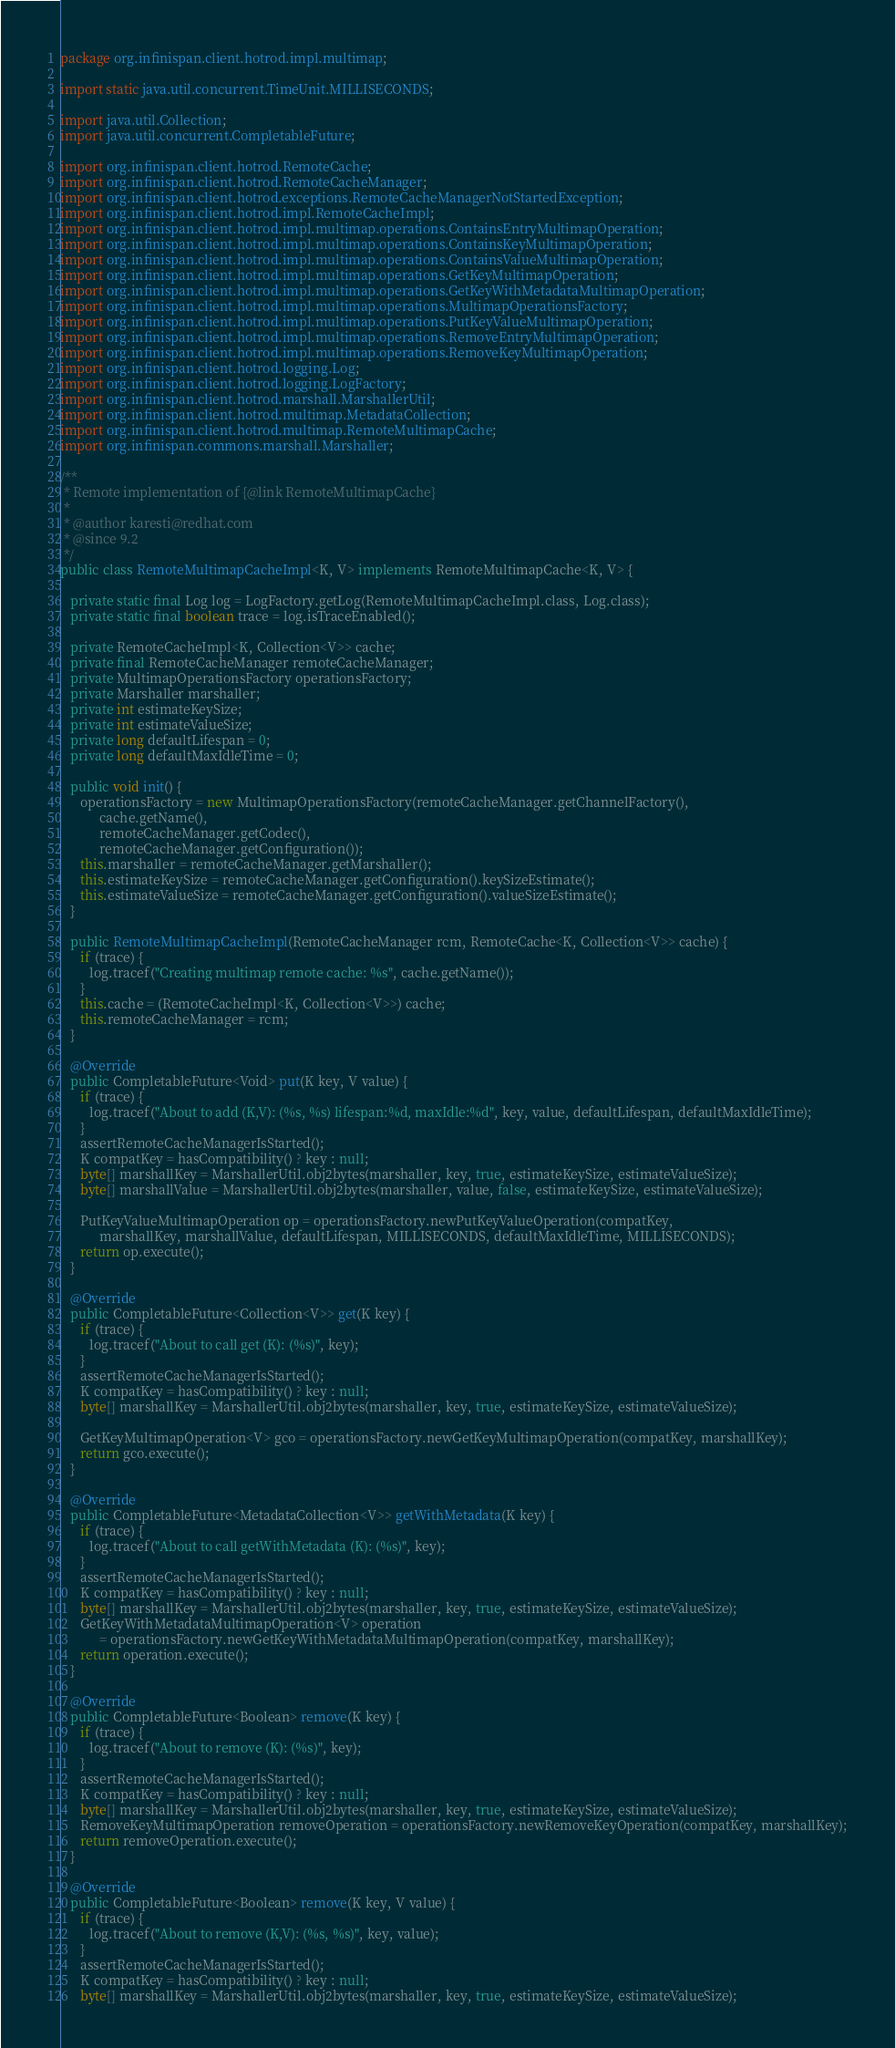<code> <loc_0><loc_0><loc_500><loc_500><_Java_>package org.infinispan.client.hotrod.impl.multimap;

import static java.util.concurrent.TimeUnit.MILLISECONDS;

import java.util.Collection;
import java.util.concurrent.CompletableFuture;

import org.infinispan.client.hotrod.RemoteCache;
import org.infinispan.client.hotrod.RemoteCacheManager;
import org.infinispan.client.hotrod.exceptions.RemoteCacheManagerNotStartedException;
import org.infinispan.client.hotrod.impl.RemoteCacheImpl;
import org.infinispan.client.hotrod.impl.multimap.operations.ContainsEntryMultimapOperation;
import org.infinispan.client.hotrod.impl.multimap.operations.ContainsKeyMultimapOperation;
import org.infinispan.client.hotrod.impl.multimap.operations.ContainsValueMultimapOperation;
import org.infinispan.client.hotrod.impl.multimap.operations.GetKeyMultimapOperation;
import org.infinispan.client.hotrod.impl.multimap.operations.GetKeyWithMetadataMultimapOperation;
import org.infinispan.client.hotrod.impl.multimap.operations.MultimapOperationsFactory;
import org.infinispan.client.hotrod.impl.multimap.operations.PutKeyValueMultimapOperation;
import org.infinispan.client.hotrod.impl.multimap.operations.RemoveEntryMultimapOperation;
import org.infinispan.client.hotrod.impl.multimap.operations.RemoveKeyMultimapOperation;
import org.infinispan.client.hotrod.logging.Log;
import org.infinispan.client.hotrod.logging.LogFactory;
import org.infinispan.client.hotrod.marshall.MarshallerUtil;
import org.infinispan.client.hotrod.multimap.MetadataCollection;
import org.infinispan.client.hotrod.multimap.RemoteMultimapCache;
import org.infinispan.commons.marshall.Marshaller;

/**
 * Remote implementation of {@link RemoteMultimapCache}
 *
 * @author karesti@redhat.com
 * @since 9.2
 */
public class RemoteMultimapCacheImpl<K, V> implements RemoteMultimapCache<K, V> {

   private static final Log log = LogFactory.getLog(RemoteMultimapCacheImpl.class, Log.class);
   private static final boolean trace = log.isTraceEnabled();

   private RemoteCacheImpl<K, Collection<V>> cache;
   private final RemoteCacheManager remoteCacheManager;
   private MultimapOperationsFactory operationsFactory;
   private Marshaller marshaller;
   private int estimateKeySize;
   private int estimateValueSize;
   private long defaultLifespan = 0;
   private long defaultMaxIdleTime = 0;

   public void init() {
      operationsFactory = new MultimapOperationsFactory(remoteCacheManager.getChannelFactory(),
            cache.getName(),
            remoteCacheManager.getCodec(),
            remoteCacheManager.getConfiguration());
      this.marshaller = remoteCacheManager.getMarshaller();
      this.estimateKeySize = remoteCacheManager.getConfiguration().keySizeEstimate();
      this.estimateValueSize = remoteCacheManager.getConfiguration().valueSizeEstimate();
   }

   public RemoteMultimapCacheImpl(RemoteCacheManager rcm, RemoteCache<K, Collection<V>> cache) {
      if (trace) {
         log.tracef("Creating multimap remote cache: %s", cache.getName());
      }
      this.cache = (RemoteCacheImpl<K, Collection<V>>) cache;
      this.remoteCacheManager = rcm;
   }

   @Override
   public CompletableFuture<Void> put(K key, V value) {
      if (trace) {
         log.tracef("About to add (K,V): (%s, %s) lifespan:%d, maxIdle:%d", key, value, defaultLifespan, defaultMaxIdleTime);
      }
      assertRemoteCacheManagerIsStarted();
      K compatKey = hasCompatibility() ? key : null;
      byte[] marshallKey = MarshallerUtil.obj2bytes(marshaller, key, true, estimateKeySize, estimateValueSize);
      byte[] marshallValue = MarshallerUtil.obj2bytes(marshaller, value, false, estimateKeySize, estimateValueSize);

      PutKeyValueMultimapOperation op = operationsFactory.newPutKeyValueOperation(compatKey,
            marshallKey, marshallValue, defaultLifespan, MILLISECONDS, defaultMaxIdleTime, MILLISECONDS);
      return op.execute();
   }

   @Override
   public CompletableFuture<Collection<V>> get(K key) {
      if (trace) {
         log.tracef("About to call get (K): (%s)", key);
      }
      assertRemoteCacheManagerIsStarted();
      K compatKey = hasCompatibility() ? key : null;
      byte[] marshallKey = MarshallerUtil.obj2bytes(marshaller, key, true, estimateKeySize, estimateValueSize);

      GetKeyMultimapOperation<V> gco = operationsFactory.newGetKeyMultimapOperation(compatKey, marshallKey);
      return gco.execute();
   }

   @Override
   public CompletableFuture<MetadataCollection<V>> getWithMetadata(K key) {
      if (trace) {
         log.tracef("About to call getWithMetadata (K): (%s)", key);
      }
      assertRemoteCacheManagerIsStarted();
      K compatKey = hasCompatibility() ? key : null;
      byte[] marshallKey = MarshallerUtil.obj2bytes(marshaller, key, true, estimateKeySize, estimateValueSize);
      GetKeyWithMetadataMultimapOperation<V> operation
            = operationsFactory.newGetKeyWithMetadataMultimapOperation(compatKey, marshallKey);
      return operation.execute();
   }

   @Override
   public CompletableFuture<Boolean> remove(K key) {
      if (trace) {
         log.tracef("About to remove (K): (%s)", key);
      }
      assertRemoteCacheManagerIsStarted();
      K compatKey = hasCompatibility() ? key : null;
      byte[] marshallKey = MarshallerUtil.obj2bytes(marshaller, key, true, estimateKeySize, estimateValueSize);
      RemoveKeyMultimapOperation removeOperation = operationsFactory.newRemoveKeyOperation(compatKey, marshallKey);
      return removeOperation.execute();
   }

   @Override
   public CompletableFuture<Boolean> remove(K key, V value) {
      if (trace) {
         log.tracef("About to remove (K,V): (%s, %s)", key, value);
      }
      assertRemoteCacheManagerIsStarted();
      K compatKey = hasCompatibility() ? key : null;
      byte[] marshallKey = MarshallerUtil.obj2bytes(marshaller, key, true, estimateKeySize, estimateValueSize);</code> 